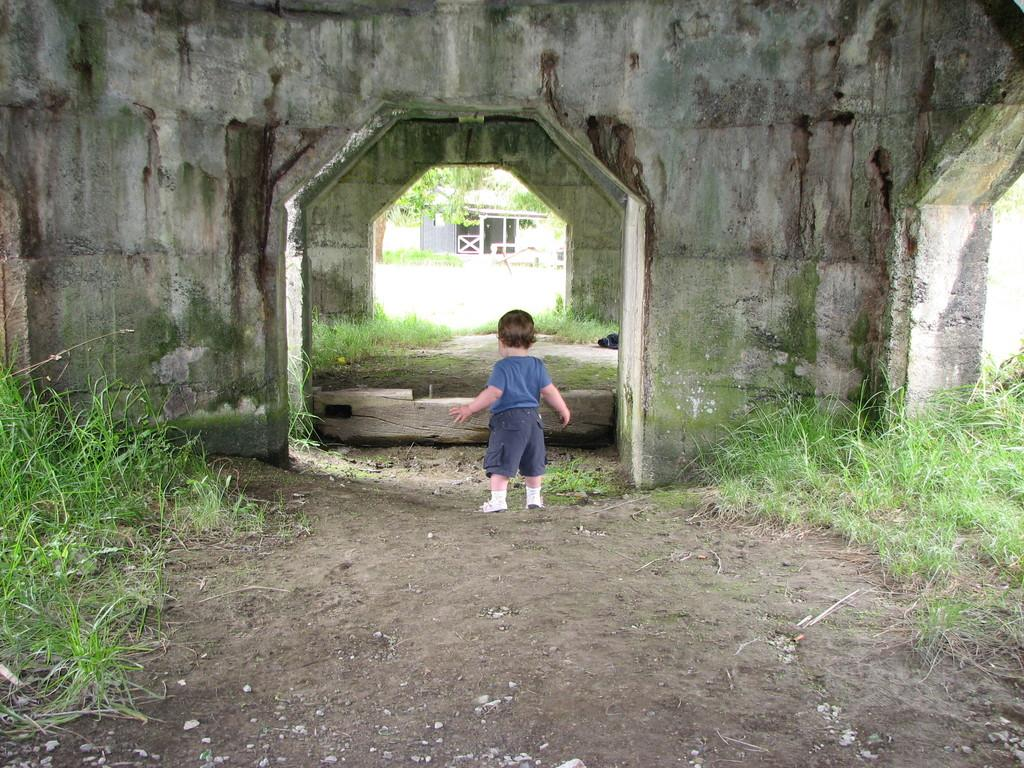What is the main subject of the image? There is a kid standing in the image. What can be seen in the background of the image? There are walls and a building in the image. What type of natural environment is visible in the image? There is grass in the image. What else can be seen in the image besides the kid and the building? There are branches in the image. Can you see any grains of rice on the kid's clothes in the image? There is no indication of grains of rice or any other food items on the kid's clothes in the image. Is there a cobweb visible in the image? There is no cobweb present in the image. 